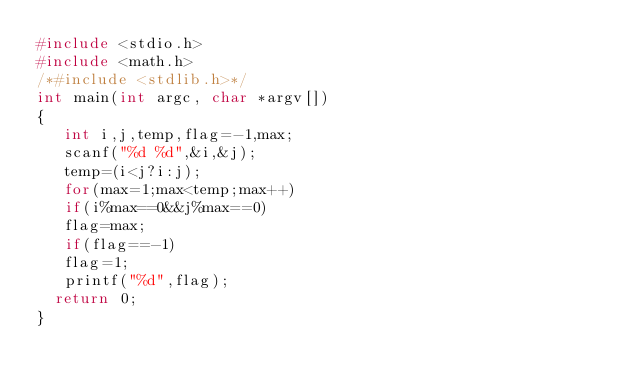Convert code to text. <code><loc_0><loc_0><loc_500><loc_500><_C_>#include <stdio.h>
#include <math.h>
/*#include <stdlib.h>*/
int main(int argc, char *argv[])
{		
   int i,j,temp,flag=-1,max;
   scanf("%d %d",&i,&j);
   temp=(i<j?i:j);
   for(max=1;max<temp;max++)
   if(i%max==0&&j%max==0)
   flag=max;
   if(flag==-1)
   flag=1;
   printf("%d",flag);
	return 0;
}</code> 